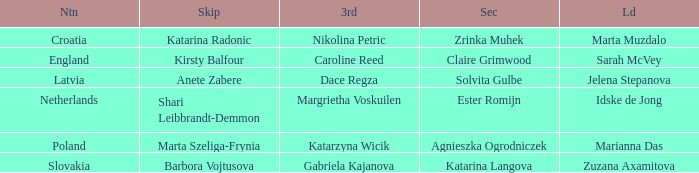Which skip has Zrinka Muhek as Second? Katarina Radonic. 